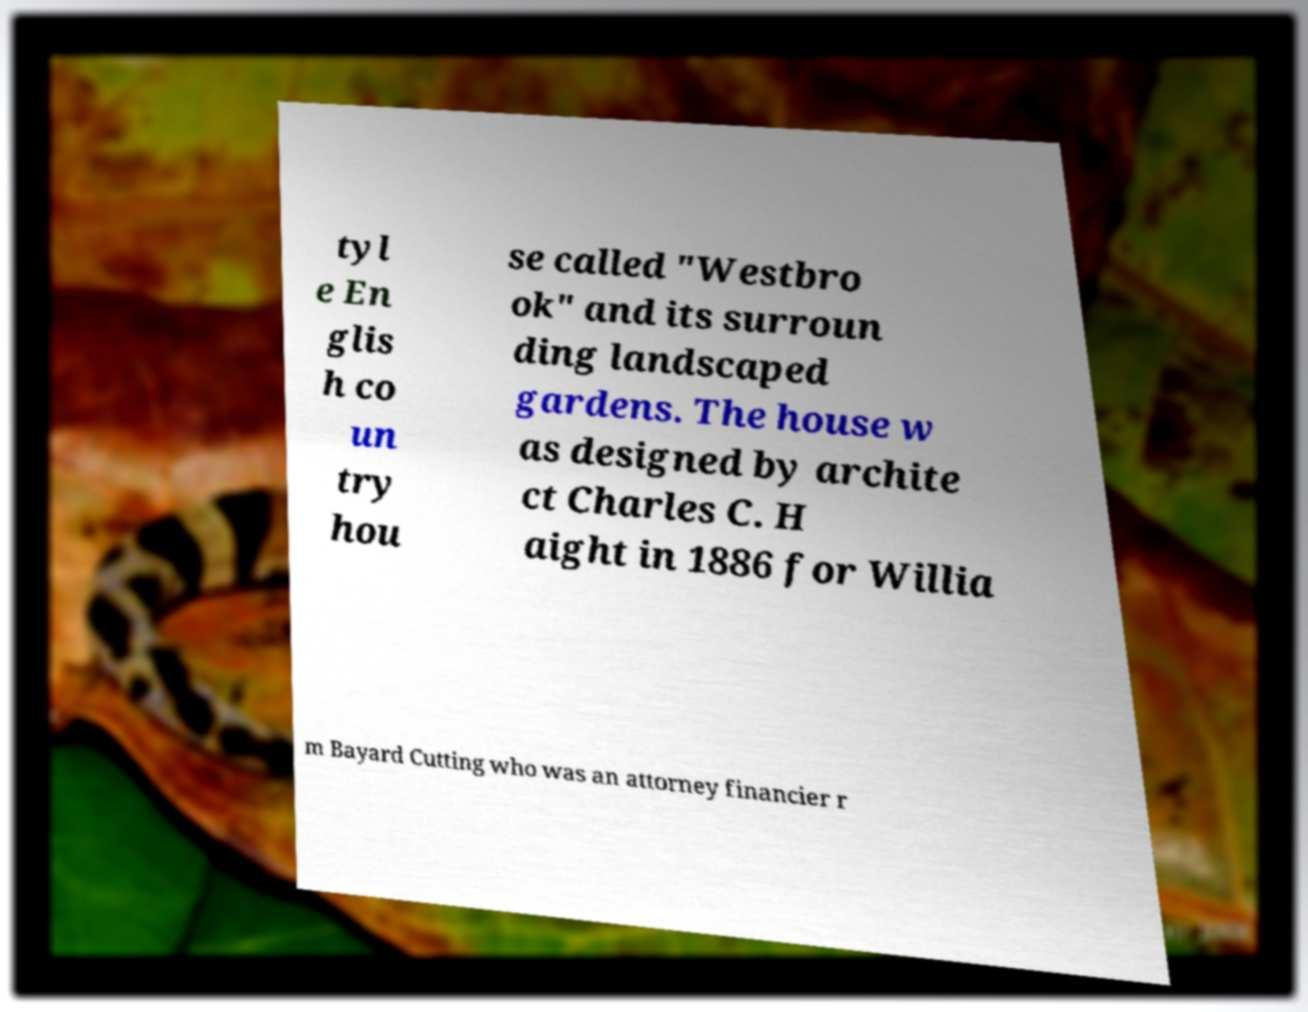Can you accurately transcribe the text from the provided image for me? tyl e En glis h co un try hou se called "Westbro ok" and its surroun ding landscaped gardens. The house w as designed by archite ct Charles C. H aight in 1886 for Willia m Bayard Cutting who was an attorney financier r 